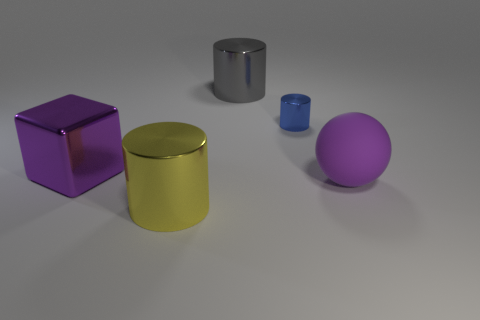Subtract all big cylinders. How many cylinders are left? 1 Subtract all gray cylinders. How many cylinders are left? 2 Subtract 2 cylinders. How many cylinders are left? 1 Subtract all blocks. How many objects are left? 4 Subtract all blue cylinders. How many yellow cubes are left? 0 Add 2 small blue metallic things. How many small blue metallic things are left? 3 Add 5 big yellow things. How many big yellow things exist? 6 Add 5 purple matte spheres. How many objects exist? 10 Subtract 0 blue spheres. How many objects are left? 5 Subtract all cyan cubes. Subtract all brown cylinders. How many cubes are left? 1 